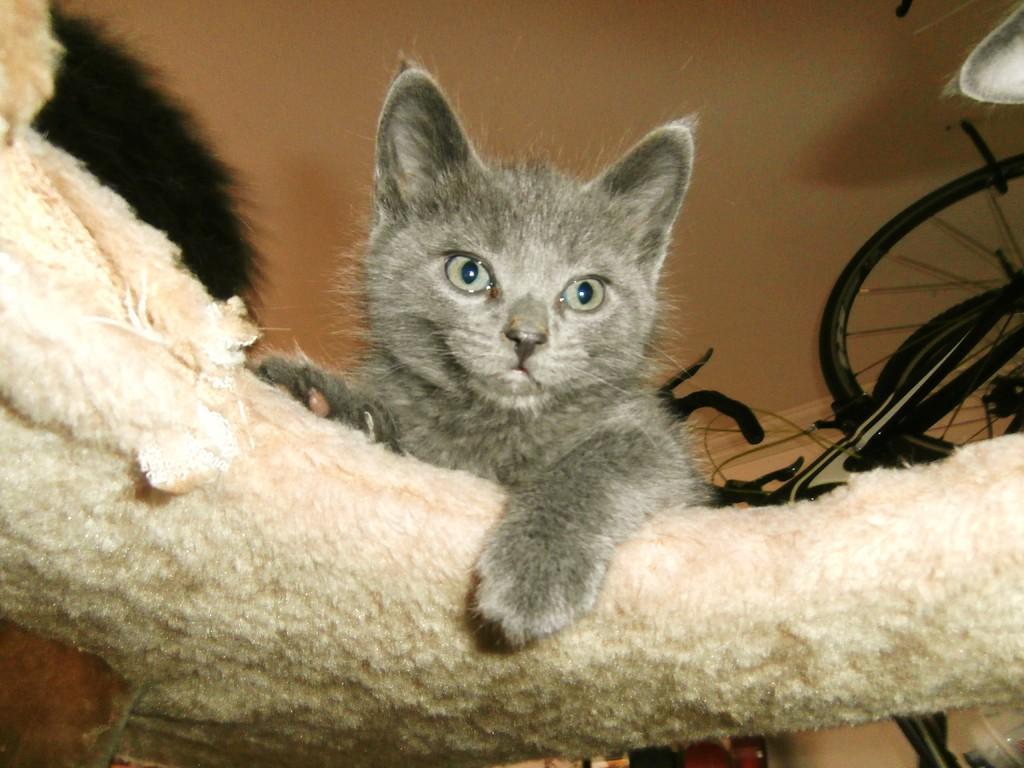Describe this image in one or two sentences. There is a cat in the center of the picture and it is placing its leg on a white color object. Behind that, we see a bicycle and a wall in cream color. 